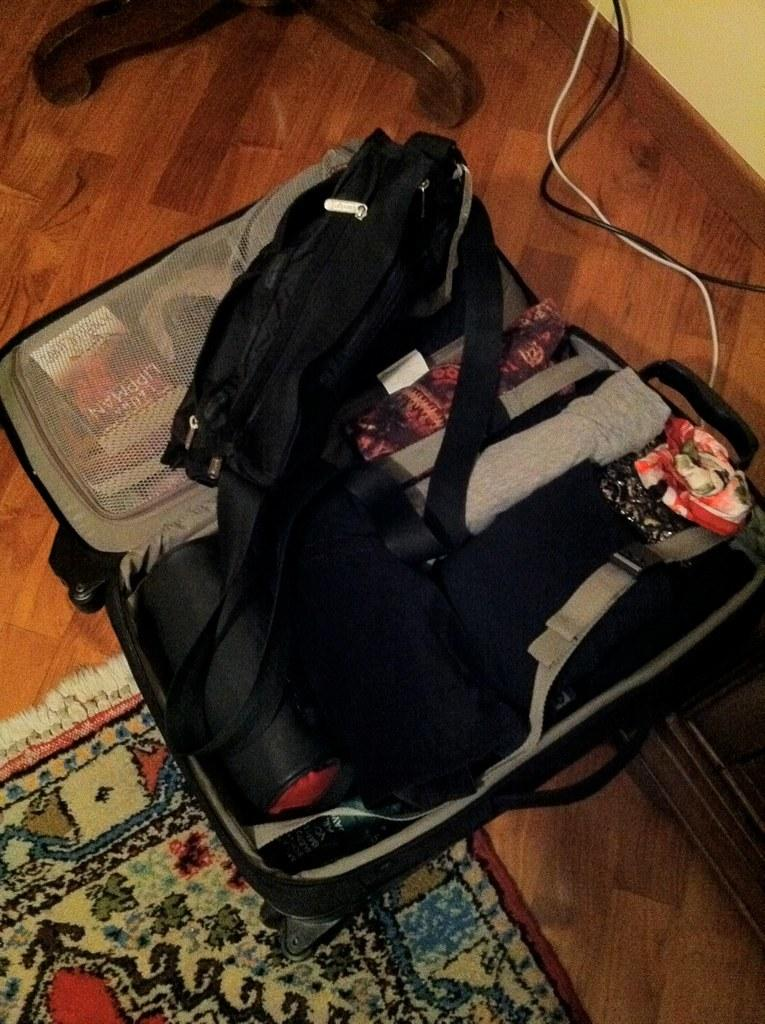What object is placed on the floor in the image? There is a briefcase on the floor. What type of material covers the floor? The floor is covered with carpet. What can be seen running along the floor in the image? There are cables visible in the image. What is present in the background of the image? There is a wall in the image. What part of the room is visible in the image? The floor is visible in the image. What type of soup is being served in the image? There is no soup present in the image. What brand of shoe can be seen on the wall in the image? There are no shoes visible in the image, let alone on the wall. 